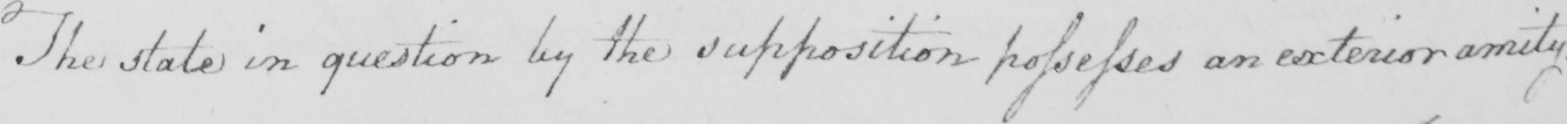Please transcribe the handwritten text in this image. The state in question by the supposition possesses an exterior amity . 